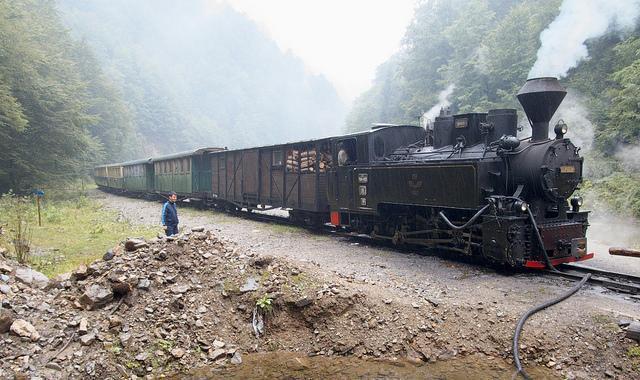How many people are standing next to the train?
Give a very brief answer. 1. How many cats have their eyes closed?
Give a very brief answer. 0. 